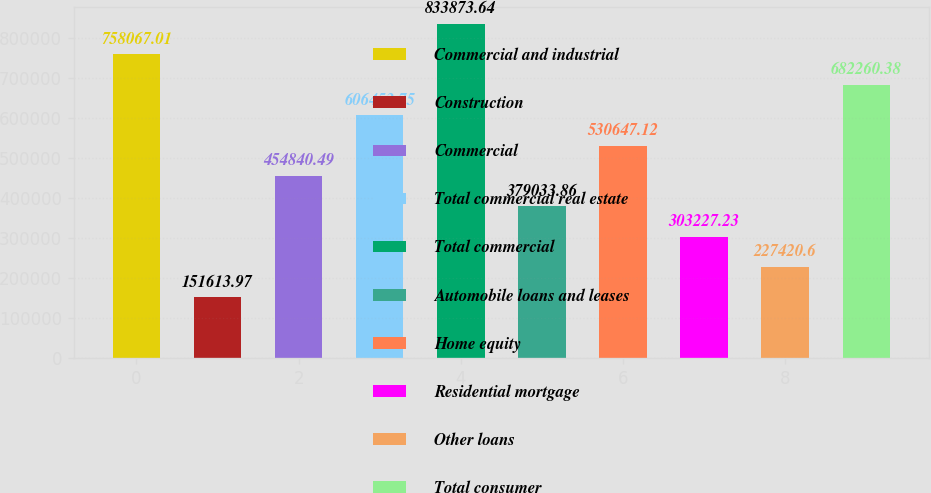<chart> <loc_0><loc_0><loc_500><loc_500><bar_chart><fcel>Commercial and industrial<fcel>Construction<fcel>Commercial<fcel>Total commercial real estate<fcel>Total commercial<fcel>Automobile loans and leases<fcel>Home equity<fcel>Residential mortgage<fcel>Other loans<fcel>Total consumer<nl><fcel>758067<fcel>151614<fcel>454840<fcel>606454<fcel>833874<fcel>379034<fcel>530647<fcel>303227<fcel>227421<fcel>682260<nl></chart> 